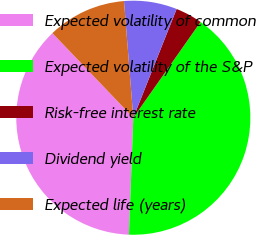<chart> <loc_0><loc_0><loc_500><loc_500><pie_chart><fcel>Expected volatility of common<fcel>Expected volatility of the S&P<fcel>Risk-free interest rate<fcel>Dividend yield<fcel>Expected life (years)<nl><fcel>37.26%<fcel>40.85%<fcel>3.71%<fcel>7.3%<fcel>10.88%<nl></chart> 